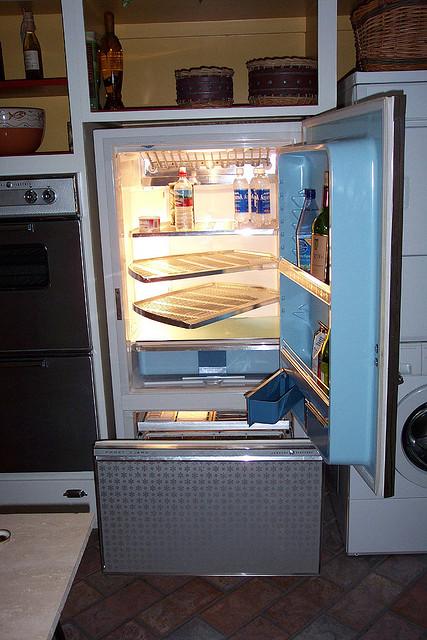Is the fridge full?
Give a very brief answer. No. Is the refrigerator open?
Keep it brief. Yes. Is this a fridge?
Write a very short answer. Yes. Does the fridge look clean?
Keep it brief. Yes. Is the light on?
Be succinct. Yes. Does there appear to be any consumable food inside the fridge?
Quick response, please. No. What is the focus of the picture?
Give a very brief answer. Refrigerator. Preservatives and what?
Answer briefly. Water. IS there water inside the refrigerator?
Write a very short answer. Yes. 